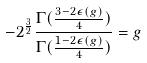<formula> <loc_0><loc_0><loc_500><loc_500>- 2 ^ { \frac { 3 } { 2 } } \frac { \Gamma ( \frac { 3 - 2 \epsilon ( g ) } { 4 } ) } { \Gamma ( \frac { 1 - 2 \epsilon ( g ) } { 4 } ) } = g</formula> 